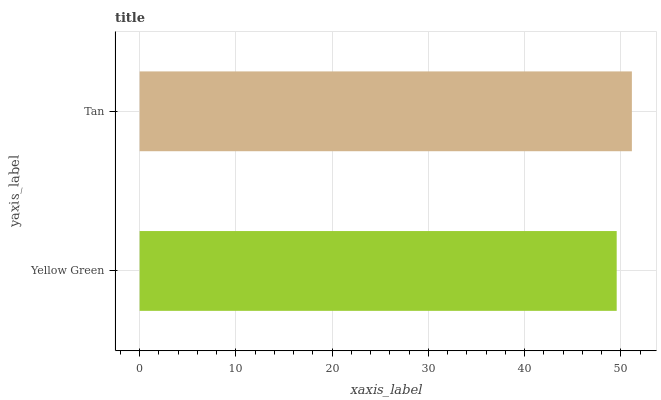Is Yellow Green the minimum?
Answer yes or no. Yes. Is Tan the maximum?
Answer yes or no. Yes. Is Tan the minimum?
Answer yes or no. No. Is Tan greater than Yellow Green?
Answer yes or no. Yes. Is Yellow Green less than Tan?
Answer yes or no. Yes. Is Yellow Green greater than Tan?
Answer yes or no. No. Is Tan less than Yellow Green?
Answer yes or no. No. Is Tan the high median?
Answer yes or no. Yes. Is Yellow Green the low median?
Answer yes or no. Yes. Is Yellow Green the high median?
Answer yes or no. No. Is Tan the low median?
Answer yes or no. No. 